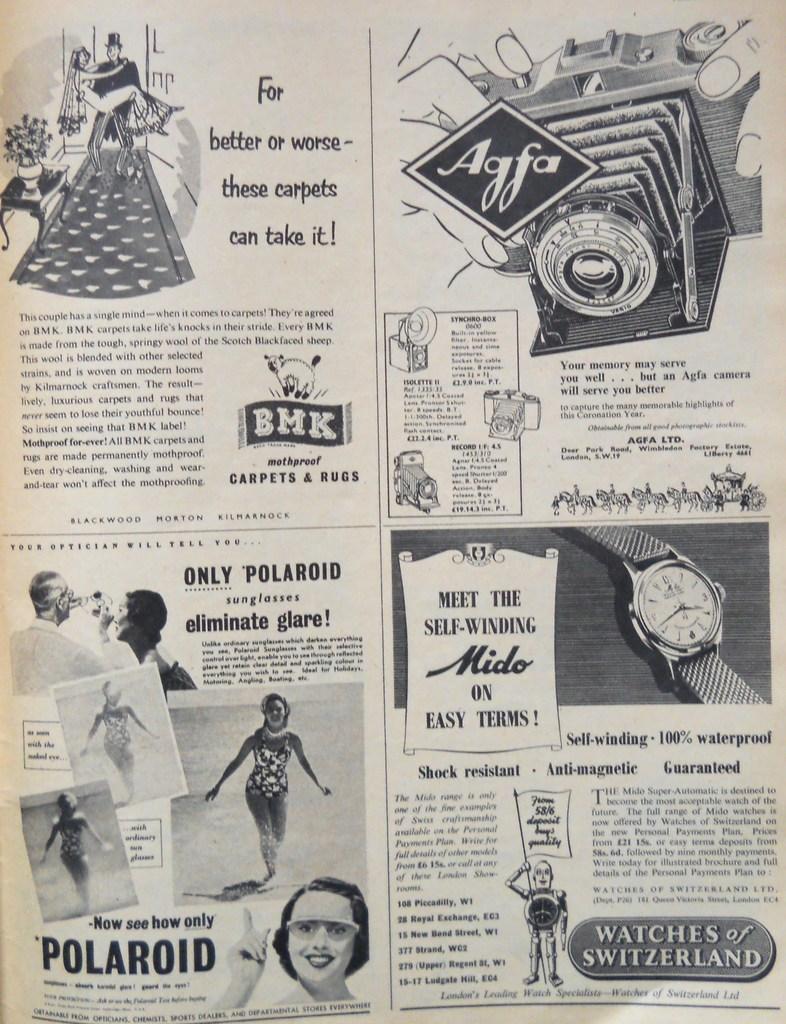How many advertisements are being shown?
Offer a terse response. 4. What company is the bottom left advertisement for?
Your answer should be compact. Polaroid. 